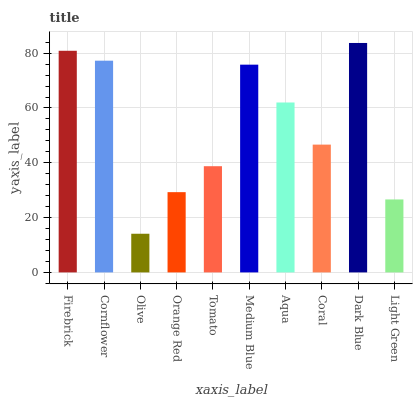Is Olive the minimum?
Answer yes or no. Yes. Is Dark Blue the maximum?
Answer yes or no. Yes. Is Cornflower the minimum?
Answer yes or no. No. Is Cornflower the maximum?
Answer yes or no. No. Is Firebrick greater than Cornflower?
Answer yes or no. Yes. Is Cornflower less than Firebrick?
Answer yes or no. Yes. Is Cornflower greater than Firebrick?
Answer yes or no. No. Is Firebrick less than Cornflower?
Answer yes or no. No. Is Aqua the high median?
Answer yes or no. Yes. Is Coral the low median?
Answer yes or no. Yes. Is Medium Blue the high median?
Answer yes or no. No. Is Dark Blue the low median?
Answer yes or no. No. 